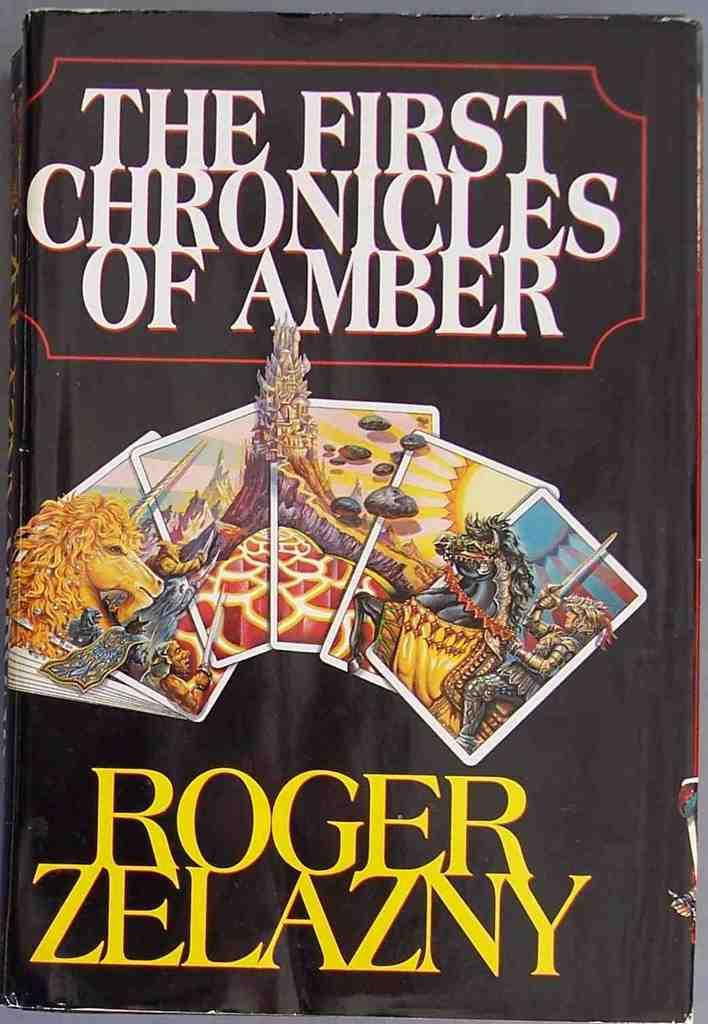<image>
Give a short and clear explanation of the subsequent image. A book titled the first chronicles of amber 